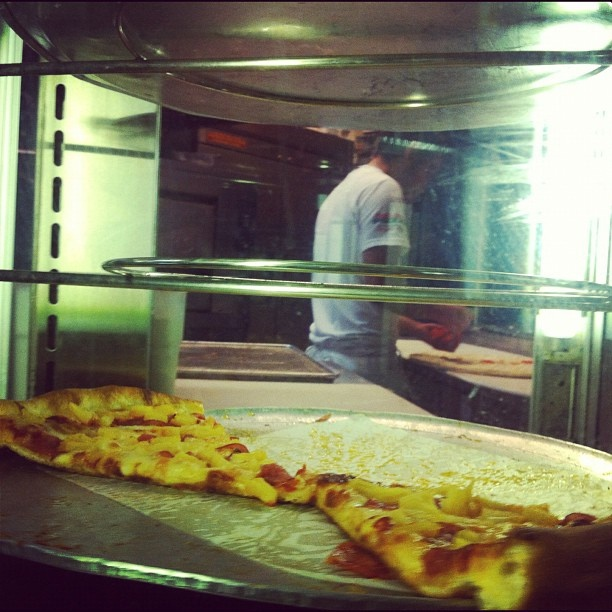Describe the objects in this image and their specific colors. I can see pizza in black, olive, and maroon tones, people in black, gray, darkgray, and lightgray tones, and pizza in black, tan, and gray tones in this image. 